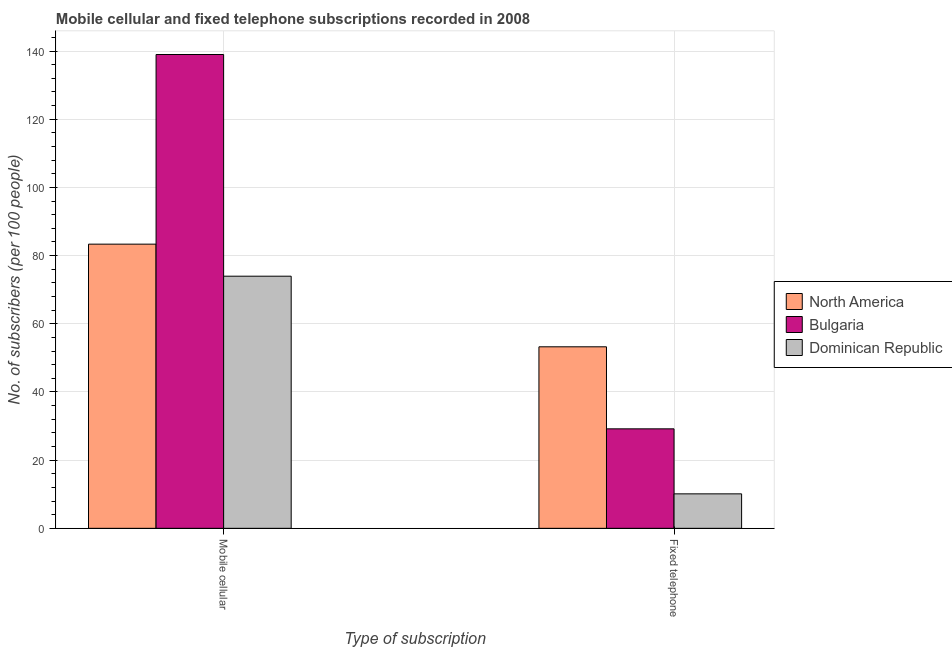Are the number of bars per tick equal to the number of legend labels?
Offer a terse response. Yes. How many bars are there on the 2nd tick from the right?
Provide a succinct answer. 3. What is the label of the 1st group of bars from the left?
Make the answer very short. Mobile cellular. What is the number of fixed telephone subscribers in North America?
Your answer should be very brief. 53.24. Across all countries, what is the maximum number of fixed telephone subscribers?
Your answer should be very brief. 53.24. Across all countries, what is the minimum number of fixed telephone subscribers?
Offer a terse response. 10.11. In which country was the number of fixed telephone subscribers maximum?
Provide a succinct answer. North America. In which country was the number of fixed telephone subscribers minimum?
Keep it short and to the point. Dominican Republic. What is the total number of fixed telephone subscribers in the graph?
Provide a short and direct response. 92.53. What is the difference between the number of fixed telephone subscribers in Bulgaria and that in Dominican Republic?
Give a very brief answer. 19.07. What is the difference between the number of fixed telephone subscribers in Dominican Republic and the number of mobile cellular subscribers in Bulgaria?
Your answer should be compact. -128.87. What is the average number of fixed telephone subscribers per country?
Your response must be concise. 30.84. What is the difference between the number of mobile cellular subscribers and number of fixed telephone subscribers in Dominican Republic?
Your response must be concise. 63.84. What is the ratio of the number of mobile cellular subscribers in Bulgaria to that in Dominican Republic?
Provide a short and direct response. 1.88. What does the 3rd bar from the left in Fixed telephone represents?
Your answer should be compact. Dominican Republic. How many countries are there in the graph?
Your answer should be very brief. 3. Are the values on the major ticks of Y-axis written in scientific E-notation?
Keep it short and to the point. No. Does the graph contain any zero values?
Offer a very short reply. No. Does the graph contain grids?
Provide a succinct answer. Yes. Where does the legend appear in the graph?
Provide a succinct answer. Center right. How are the legend labels stacked?
Your response must be concise. Vertical. What is the title of the graph?
Give a very brief answer. Mobile cellular and fixed telephone subscriptions recorded in 2008. Does "Japan" appear as one of the legend labels in the graph?
Provide a short and direct response. No. What is the label or title of the X-axis?
Provide a short and direct response. Type of subscription. What is the label or title of the Y-axis?
Give a very brief answer. No. of subscribers (per 100 people). What is the No. of subscribers (per 100 people) of North America in Mobile cellular?
Provide a succinct answer. 83.35. What is the No. of subscribers (per 100 people) of Bulgaria in Mobile cellular?
Provide a short and direct response. 138.98. What is the No. of subscribers (per 100 people) of Dominican Republic in Mobile cellular?
Your answer should be very brief. 73.95. What is the No. of subscribers (per 100 people) of North America in Fixed telephone?
Your answer should be compact. 53.24. What is the No. of subscribers (per 100 people) in Bulgaria in Fixed telephone?
Give a very brief answer. 29.18. What is the No. of subscribers (per 100 people) of Dominican Republic in Fixed telephone?
Offer a terse response. 10.11. Across all Type of subscription, what is the maximum No. of subscribers (per 100 people) of North America?
Offer a very short reply. 83.35. Across all Type of subscription, what is the maximum No. of subscribers (per 100 people) in Bulgaria?
Make the answer very short. 138.98. Across all Type of subscription, what is the maximum No. of subscribers (per 100 people) of Dominican Republic?
Offer a terse response. 73.95. Across all Type of subscription, what is the minimum No. of subscribers (per 100 people) in North America?
Offer a terse response. 53.24. Across all Type of subscription, what is the minimum No. of subscribers (per 100 people) of Bulgaria?
Your answer should be very brief. 29.18. Across all Type of subscription, what is the minimum No. of subscribers (per 100 people) of Dominican Republic?
Make the answer very short. 10.11. What is the total No. of subscribers (per 100 people) of North America in the graph?
Make the answer very short. 136.59. What is the total No. of subscribers (per 100 people) of Bulgaria in the graph?
Offer a terse response. 168.16. What is the total No. of subscribers (per 100 people) in Dominican Republic in the graph?
Your answer should be very brief. 84.06. What is the difference between the No. of subscribers (per 100 people) in North America in Mobile cellular and that in Fixed telephone?
Make the answer very short. 30.11. What is the difference between the No. of subscribers (per 100 people) of Bulgaria in Mobile cellular and that in Fixed telephone?
Your answer should be compact. 109.79. What is the difference between the No. of subscribers (per 100 people) in Dominican Republic in Mobile cellular and that in Fixed telephone?
Provide a succinct answer. 63.84. What is the difference between the No. of subscribers (per 100 people) of North America in Mobile cellular and the No. of subscribers (per 100 people) of Bulgaria in Fixed telephone?
Your answer should be very brief. 54.17. What is the difference between the No. of subscribers (per 100 people) in North America in Mobile cellular and the No. of subscribers (per 100 people) in Dominican Republic in Fixed telephone?
Make the answer very short. 73.24. What is the difference between the No. of subscribers (per 100 people) in Bulgaria in Mobile cellular and the No. of subscribers (per 100 people) in Dominican Republic in Fixed telephone?
Provide a succinct answer. 128.87. What is the average No. of subscribers (per 100 people) of North America per Type of subscription?
Your answer should be compact. 68.3. What is the average No. of subscribers (per 100 people) of Bulgaria per Type of subscription?
Ensure brevity in your answer.  84.08. What is the average No. of subscribers (per 100 people) of Dominican Republic per Type of subscription?
Your answer should be compact. 42.03. What is the difference between the No. of subscribers (per 100 people) in North America and No. of subscribers (per 100 people) in Bulgaria in Mobile cellular?
Give a very brief answer. -55.62. What is the difference between the No. of subscribers (per 100 people) of North America and No. of subscribers (per 100 people) of Dominican Republic in Mobile cellular?
Your response must be concise. 9.4. What is the difference between the No. of subscribers (per 100 people) of Bulgaria and No. of subscribers (per 100 people) of Dominican Republic in Mobile cellular?
Offer a terse response. 65.02. What is the difference between the No. of subscribers (per 100 people) of North America and No. of subscribers (per 100 people) of Bulgaria in Fixed telephone?
Your response must be concise. 24.06. What is the difference between the No. of subscribers (per 100 people) in North America and No. of subscribers (per 100 people) in Dominican Republic in Fixed telephone?
Give a very brief answer. 43.13. What is the difference between the No. of subscribers (per 100 people) of Bulgaria and No. of subscribers (per 100 people) of Dominican Republic in Fixed telephone?
Provide a short and direct response. 19.07. What is the ratio of the No. of subscribers (per 100 people) of North America in Mobile cellular to that in Fixed telephone?
Offer a terse response. 1.57. What is the ratio of the No. of subscribers (per 100 people) of Bulgaria in Mobile cellular to that in Fixed telephone?
Provide a succinct answer. 4.76. What is the ratio of the No. of subscribers (per 100 people) of Dominican Republic in Mobile cellular to that in Fixed telephone?
Ensure brevity in your answer.  7.32. What is the difference between the highest and the second highest No. of subscribers (per 100 people) in North America?
Provide a short and direct response. 30.11. What is the difference between the highest and the second highest No. of subscribers (per 100 people) in Bulgaria?
Your response must be concise. 109.79. What is the difference between the highest and the second highest No. of subscribers (per 100 people) in Dominican Republic?
Offer a very short reply. 63.84. What is the difference between the highest and the lowest No. of subscribers (per 100 people) of North America?
Provide a short and direct response. 30.11. What is the difference between the highest and the lowest No. of subscribers (per 100 people) in Bulgaria?
Your response must be concise. 109.79. What is the difference between the highest and the lowest No. of subscribers (per 100 people) of Dominican Republic?
Provide a short and direct response. 63.84. 